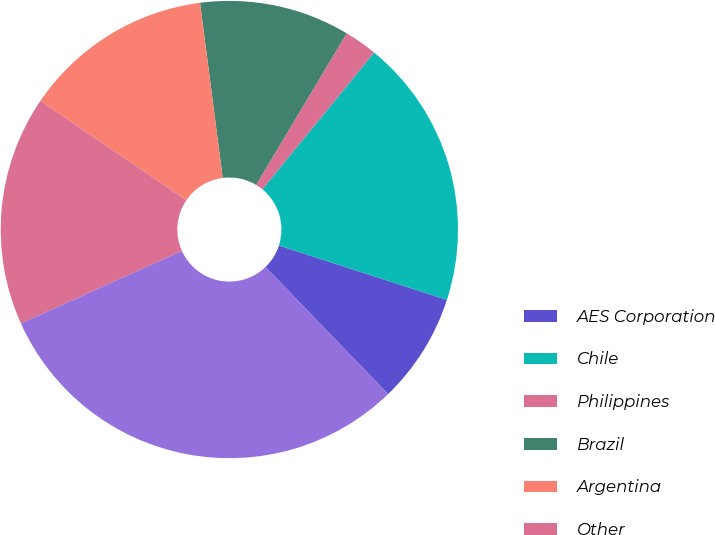Convert chart. <chart><loc_0><loc_0><loc_500><loc_500><pie_chart><fcel>AES Corporation<fcel>Chile<fcel>Philippines<fcel>Brazil<fcel>Argentina<fcel>Other<fcel>Total (1)<nl><fcel>7.81%<fcel>19.06%<fcel>2.34%<fcel>10.62%<fcel>13.44%<fcel>16.25%<fcel>30.47%<nl></chart> 